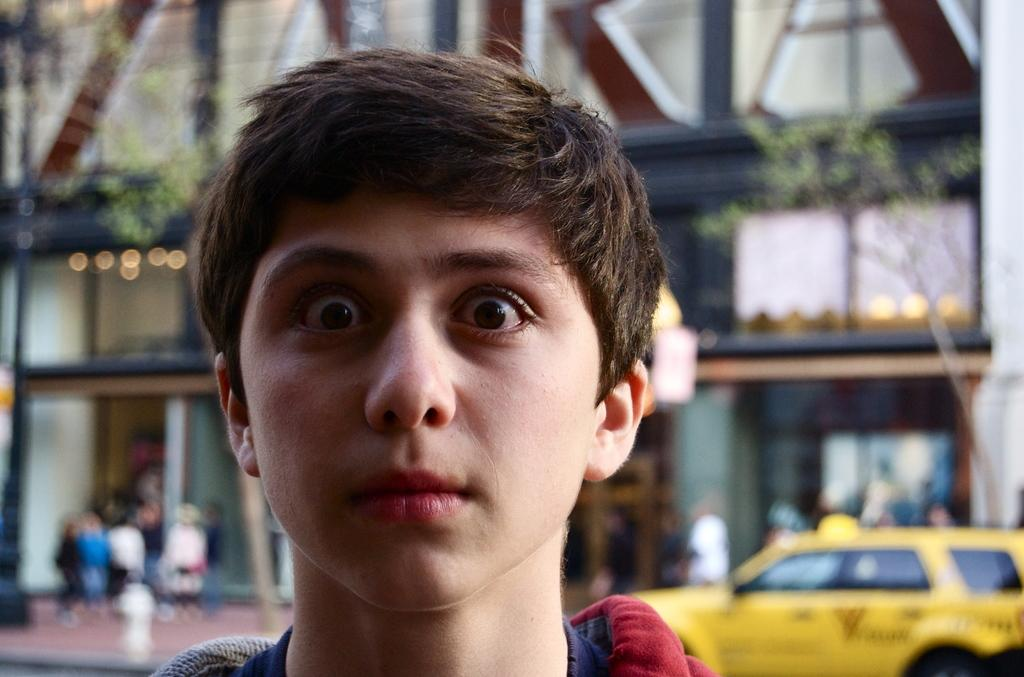Who is the main subject in the image? There is a boy in the image. What can be seen in the background of the image? There is a car parked, trees, and buildings in the background of the image. What type of veil can be seen on the boy in the image? There is no veil present on the boy in the image. How many geese are visible in the image? There are no geese present in the image. 